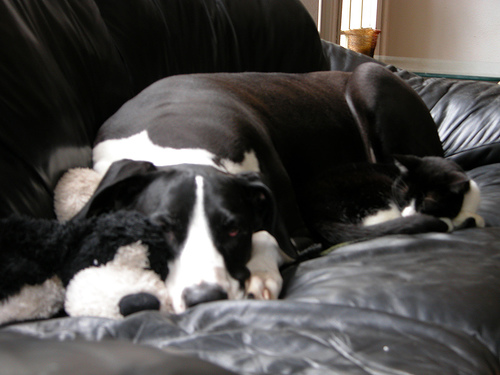Is the focus blurry? The image appears to have a soft focus, which gives a gentle, dreamy quality to the scene of the dog and cat resting together. 